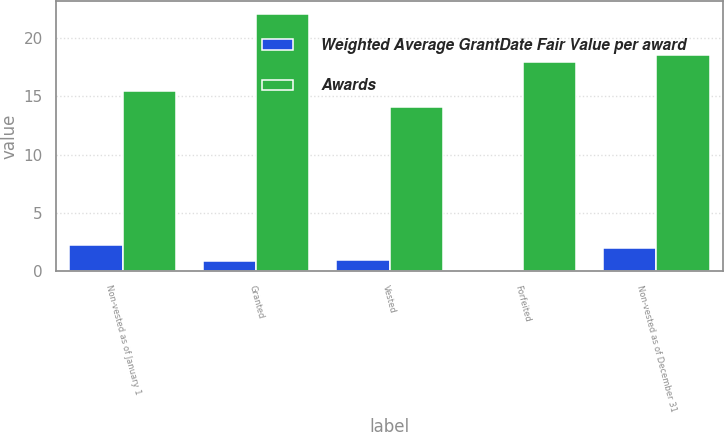<chart> <loc_0><loc_0><loc_500><loc_500><stacked_bar_chart><ecel><fcel>Non-vested as of January 1<fcel>Granted<fcel>Vested<fcel>Forfeited<fcel>Non-vested as of December 31<nl><fcel>Weighted Average GrantDate Fair Value per award<fcel>2.2<fcel>0.8<fcel>0.9<fcel>0.1<fcel>2<nl><fcel>Awards<fcel>15.47<fcel>22.07<fcel>14.1<fcel>17.92<fcel>18.53<nl></chart> 